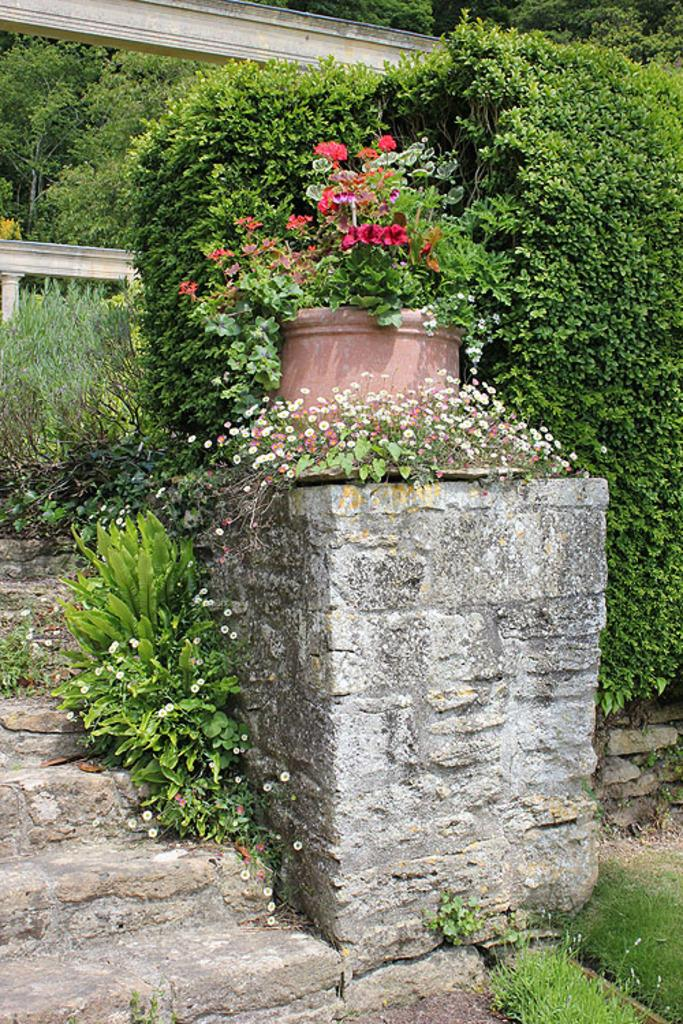What color are the trees in the image? The trees in the image are green. What else in the image shares the same color as the trees? There are green color plants in the image. Is there a thrilling bridge visible in the image? There is no bridge present in the image, let alone a thrilling one. 